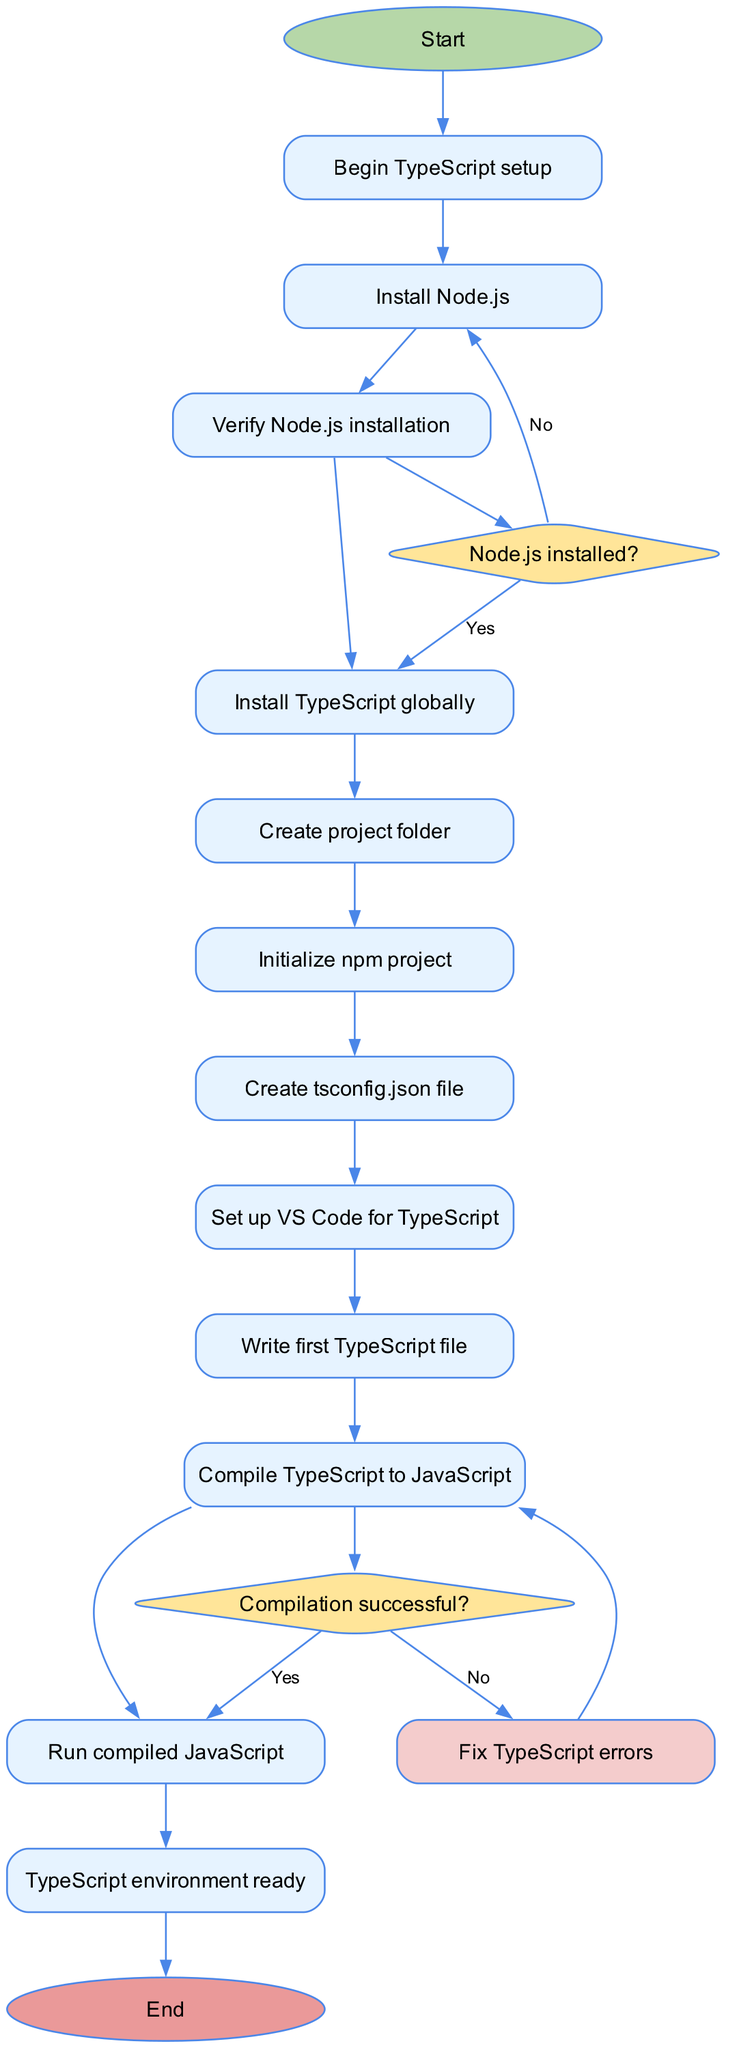What is the first activity in the diagram? The first activity that follows the start point is "Install Node.js". This is explicitly outlined as the first step in the flow of activities shown in the diagram.
Answer: Install Node.js How many activities are there in total? There are 10 activities listed in the diagram, all of which represent different steps in setting up the TypeScript development environment.
Answer: 10 What is the question asked after verifying Node.js installation? The next question asked is "Node.js installed?" This decision occurs immediately after the activity of verifying the Node.js installation.
Answer: Node.js installed? What happens if the compilation of TypeScript is not successful? If the compilation is not successful, the flow directs to "Fix TypeScript errors". This is a clear path in the decision node that deals with compilation status.
Answer: Fix TypeScript errors What is the relationship between "Compile TypeScript to JavaScript" and the decision about compilation success? "Compile TypeScript to JavaScript" leads to the decision node regarding whether the compilation was successful, establishing a direct connection between the compilation action and the success check.
Answer: Leads to decision When does the setup process end? The setup process ends after the activity "Run compiled JavaScript", indicated by an edge that leads from that activity to the end node in the diagram.
Answer: After Run compiled JavaScript What is the decision made right after creating the tsconfig.json file? The decision made after "Create tsconfig.json file" is about whether Node.js is installed, guiding the process based on Node.js status.
Answer: Node.js installed? 